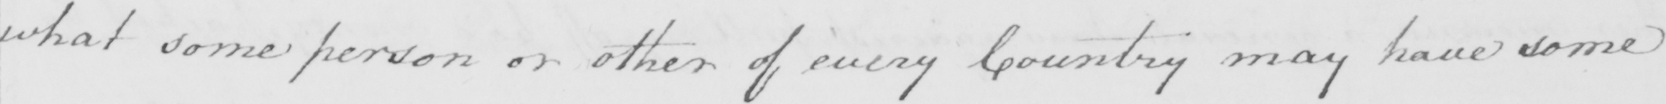Please provide the text content of this handwritten line. what some person or other of every Country may have some 